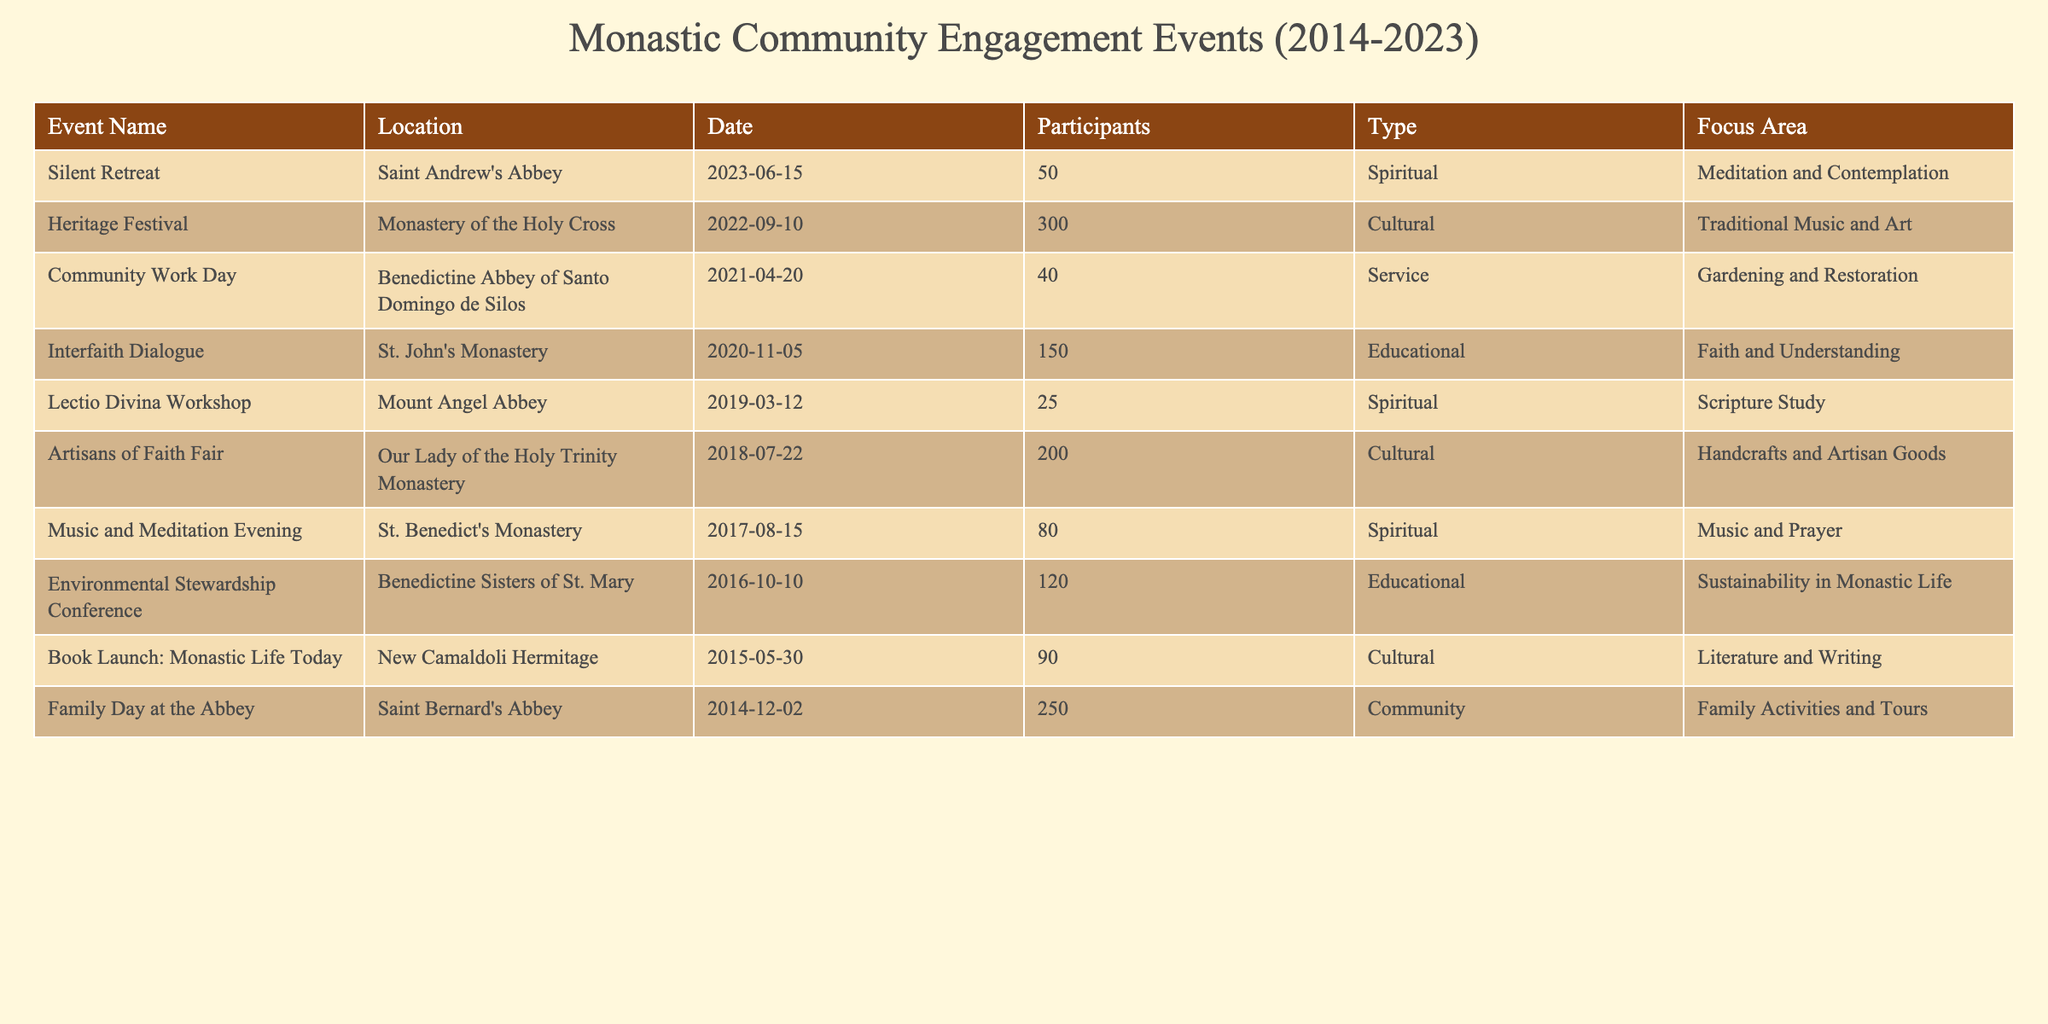What was the location of the "Silent Retreat"? The location is directly provided in the table under the Location column for the "Silent Retreat" event. It shows "Saint Andrew's Abbey" as the location.
Answer: Saint Andrew's Abbey How many participants attended the "Community Work Day"? The number of participants is listed in the Participants column for the "Community Work Day" event. The table indicates 40 participants attended this event.
Answer: 40 Which type of event had the highest number of participants? To find the event with the highest number of participants, we compare the values in the Participants column. The highest value is 300 participants for the "Heritage Festival".
Answer: Heritage Festival What is the total number of participants across all events? To get the total number of participants, we sum the values from the Participants column: 50 + 300 + 40 + 150 + 25 + 200 + 80 + 120 + 90 + 250 = 1,605.
Answer: 1605 Was there a "Lectio Divina Workshop" in the year 2019? Checking the Event Name column, we find "Lectio Divina Workshop" listed, and its date indicates it occurred in 2019. Therefore, the answer is yes.
Answer: Yes How many educational events were held in total? By filtering the Type column for "Educational", we find two events: "Interfaith Dialogue" and "Environmental Stewardship Conference". So there are two educational events.
Answer: 2 What was the average number of participants in spiritual events? We identify the spiritual events from the Type column: "Silent Retreat", "Lectio Divina Workshop", "Music and Meditation Evening", totaling 50 + 25 + 80 = 155 participants. There are 3 spiritual events, so the average is 155 / 3 = 51.67.
Answer: 51.67 Which event had the cultural focus area and occurred before 2016? From the table, we look for cultural events before 2016. The "Book Launch: Monastic Life Today" in 2015 fits this criterion. Therefore, the answer is that this event fits.
Answer: Book Launch: Monastic Life Today What is the focus area of the "Family Day at the Abbey"? The focus area is simply listed next to the event in the Focus Area column. It shows "Family Activities and Tours" for the "Family Day at the Abbey".
Answer: Family Activities and Tours 